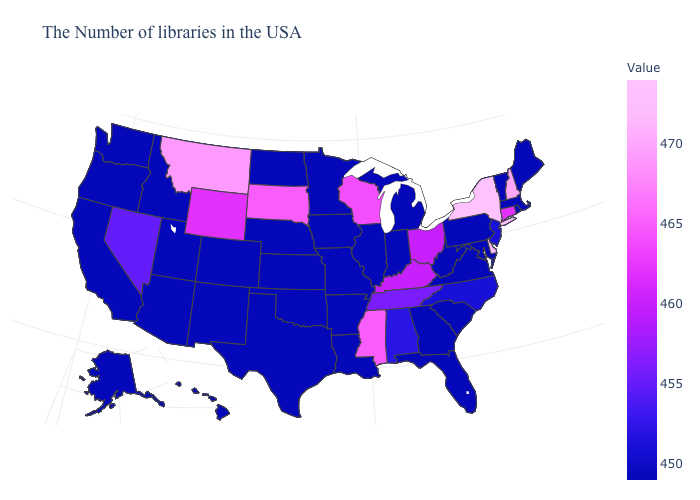Does Utah have the highest value in the West?
Be succinct. No. Does Texas have the highest value in the South?
Quick response, please. No. Which states have the lowest value in the West?
Answer briefly. Colorado, New Mexico, Utah, Arizona, Idaho, California, Washington, Oregon, Alaska, Hawaii. Does New York have the highest value in the USA?
Write a very short answer. Yes. Does the map have missing data?
Answer briefly. No. Does Delaware have the lowest value in the USA?
Concise answer only. No. Is the legend a continuous bar?
Be succinct. Yes. 